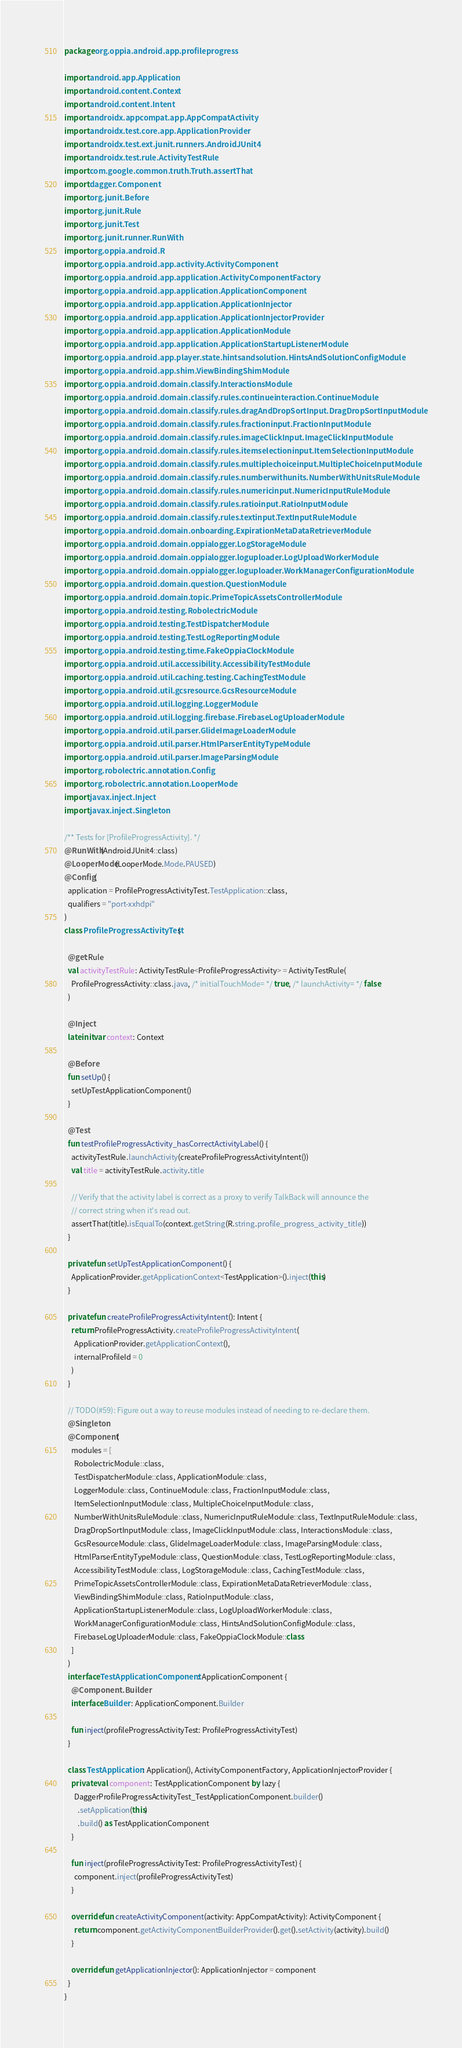Convert code to text. <code><loc_0><loc_0><loc_500><loc_500><_Kotlin_>package org.oppia.android.app.profileprogress

import android.app.Application
import android.content.Context
import android.content.Intent
import androidx.appcompat.app.AppCompatActivity
import androidx.test.core.app.ApplicationProvider
import androidx.test.ext.junit.runners.AndroidJUnit4
import androidx.test.rule.ActivityTestRule
import com.google.common.truth.Truth.assertThat
import dagger.Component
import org.junit.Before
import org.junit.Rule
import org.junit.Test
import org.junit.runner.RunWith
import org.oppia.android.R
import org.oppia.android.app.activity.ActivityComponent
import org.oppia.android.app.application.ActivityComponentFactory
import org.oppia.android.app.application.ApplicationComponent
import org.oppia.android.app.application.ApplicationInjector
import org.oppia.android.app.application.ApplicationInjectorProvider
import org.oppia.android.app.application.ApplicationModule
import org.oppia.android.app.application.ApplicationStartupListenerModule
import org.oppia.android.app.player.state.hintsandsolution.HintsAndSolutionConfigModule
import org.oppia.android.app.shim.ViewBindingShimModule
import org.oppia.android.domain.classify.InteractionsModule
import org.oppia.android.domain.classify.rules.continueinteraction.ContinueModule
import org.oppia.android.domain.classify.rules.dragAndDropSortInput.DragDropSortInputModule
import org.oppia.android.domain.classify.rules.fractioninput.FractionInputModule
import org.oppia.android.domain.classify.rules.imageClickInput.ImageClickInputModule
import org.oppia.android.domain.classify.rules.itemselectioninput.ItemSelectionInputModule
import org.oppia.android.domain.classify.rules.multiplechoiceinput.MultipleChoiceInputModule
import org.oppia.android.domain.classify.rules.numberwithunits.NumberWithUnitsRuleModule
import org.oppia.android.domain.classify.rules.numericinput.NumericInputRuleModule
import org.oppia.android.domain.classify.rules.ratioinput.RatioInputModule
import org.oppia.android.domain.classify.rules.textinput.TextInputRuleModule
import org.oppia.android.domain.onboarding.ExpirationMetaDataRetrieverModule
import org.oppia.android.domain.oppialogger.LogStorageModule
import org.oppia.android.domain.oppialogger.loguploader.LogUploadWorkerModule
import org.oppia.android.domain.oppialogger.loguploader.WorkManagerConfigurationModule
import org.oppia.android.domain.question.QuestionModule
import org.oppia.android.domain.topic.PrimeTopicAssetsControllerModule
import org.oppia.android.testing.RobolectricModule
import org.oppia.android.testing.TestDispatcherModule
import org.oppia.android.testing.TestLogReportingModule
import org.oppia.android.testing.time.FakeOppiaClockModule
import org.oppia.android.util.accessibility.AccessibilityTestModule
import org.oppia.android.util.caching.testing.CachingTestModule
import org.oppia.android.util.gcsresource.GcsResourceModule
import org.oppia.android.util.logging.LoggerModule
import org.oppia.android.util.logging.firebase.FirebaseLogUploaderModule
import org.oppia.android.util.parser.GlideImageLoaderModule
import org.oppia.android.util.parser.HtmlParserEntityTypeModule
import org.oppia.android.util.parser.ImageParsingModule
import org.robolectric.annotation.Config
import org.robolectric.annotation.LooperMode
import javax.inject.Inject
import javax.inject.Singleton

/** Tests for [ProfileProgressActivity]. */
@RunWith(AndroidJUnit4::class)
@LooperMode(LooperMode.Mode.PAUSED)
@Config(
  application = ProfileProgressActivityTest.TestApplication::class,
  qualifiers = "port-xxhdpi"
)
class ProfileProgressActivityTest {

  @get:Rule
  val activityTestRule: ActivityTestRule<ProfileProgressActivity> = ActivityTestRule(
    ProfileProgressActivity::class.java, /* initialTouchMode= */ true, /* launchActivity= */ false
  )

  @Inject
  lateinit var context: Context

  @Before
  fun setUp() {
    setUpTestApplicationComponent()
  }

  @Test
  fun testProfileProgressActivity_hasCorrectActivityLabel() {
    activityTestRule.launchActivity(createProfileProgressActivityIntent())
    val title = activityTestRule.activity.title

    // Verify that the activity label is correct as a proxy to verify TalkBack will announce the
    // correct string when it's read out.
    assertThat(title).isEqualTo(context.getString(R.string.profile_progress_activity_title))
  }

  private fun setUpTestApplicationComponent() {
    ApplicationProvider.getApplicationContext<TestApplication>().inject(this)
  }

  private fun createProfileProgressActivityIntent(): Intent {
    return ProfileProgressActivity.createProfileProgressActivityIntent(
      ApplicationProvider.getApplicationContext(),
      internalProfileId = 0
    )
  }

  // TODO(#59): Figure out a way to reuse modules instead of needing to re-declare them.
  @Singleton
  @Component(
    modules = [
      RobolectricModule::class,
      TestDispatcherModule::class, ApplicationModule::class,
      LoggerModule::class, ContinueModule::class, FractionInputModule::class,
      ItemSelectionInputModule::class, MultipleChoiceInputModule::class,
      NumberWithUnitsRuleModule::class, NumericInputRuleModule::class, TextInputRuleModule::class,
      DragDropSortInputModule::class, ImageClickInputModule::class, InteractionsModule::class,
      GcsResourceModule::class, GlideImageLoaderModule::class, ImageParsingModule::class,
      HtmlParserEntityTypeModule::class, QuestionModule::class, TestLogReportingModule::class,
      AccessibilityTestModule::class, LogStorageModule::class, CachingTestModule::class,
      PrimeTopicAssetsControllerModule::class, ExpirationMetaDataRetrieverModule::class,
      ViewBindingShimModule::class, RatioInputModule::class,
      ApplicationStartupListenerModule::class, LogUploadWorkerModule::class,
      WorkManagerConfigurationModule::class, HintsAndSolutionConfigModule::class,
      FirebaseLogUploaderModule::class, FakeOppiaClockModule::class
    ]
  )
  interface TestApplicationComponent : ApplicationComponent {
    @Component.Builder
    interface Builder : ApplicationComponent.Builder

    fun inject(profileProgressActivityTest: ProfileProgressActivityTest)
  }

  class TestApplication : Application(), ActivityComponentFactory, ApplicationInjectorProvider {
    private val component: TestApplicationComponent by lazy {
      DaggerProfileProgressActivityTest_TestApplicationComponent.builder()
        .setApplication(this)
        .build() as TestApplicationComponent
    }

    fun inject(profileProgressActivityTest: ProfileProgressActivityTest) {
      component.inject(profileProgressActivityTest)
    }

    override fun createActivityComponent(activity: AppCompatActivity): ActivityComponent {
      return component.getActivityComponentBuilderProvider().get().setActivity(activity).build()
    }

    override fun getApplicationInjector(): ApplicationInjector = component
  }
}
</code> 